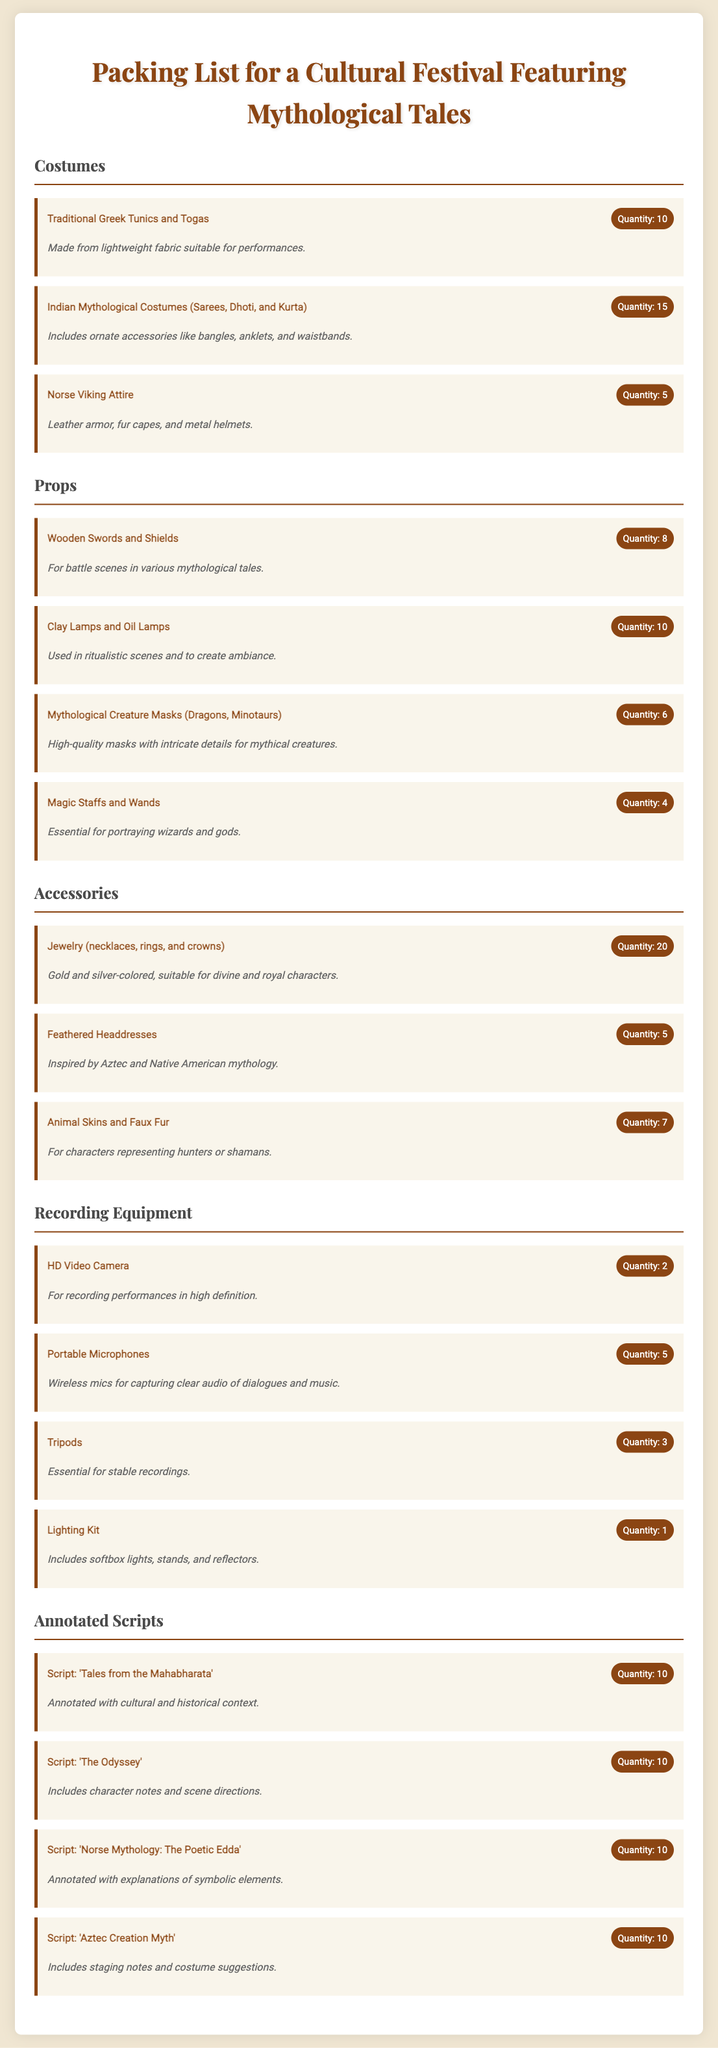what is the quantity of Indian Mythological Costumes? The quantity is directly stated in the item description for Indian Mythological Costumes.
Answer: 15 how many types of props are listed? The types of props can be counted from the props section in the document.
Answer: 4 what is the quantity of HD Video Cameras? The quantity of HD Video Cameras is specified under the recording equipment category.
Answer: 2 which costume has the least quantity? By comparing the quantities of each costume listed, we find the one with the smallest amount.
Answer: 5 what type of accessories have a quantity of 20? The accessories section includes an item that is noted with a quantity of 20.
Answer: Jewelry (necklaces, rings, and crowns) what is the purpose of the Clay Lamps and Oil Lamps? The purpose is mentioned in the notes accompanying the props, detailing their use in the festival.
Answer: To create ambiance which script is annotated with cultural and historical context? The specific script noted with cultural and historical context will directly answer the question.
Answer: 'Tales from the Mahabharata' how many Magic Staffs and Wands are being packed? The quantity can be found under the props section detailing the Magic Staffs and Wands.
Answer: 4 what type of costumes are made from lightweight fabric? The description in the costumes section provides the answer regarding the material used for specific costumes.
Answer: Traditional Greek Tunics and Togas 